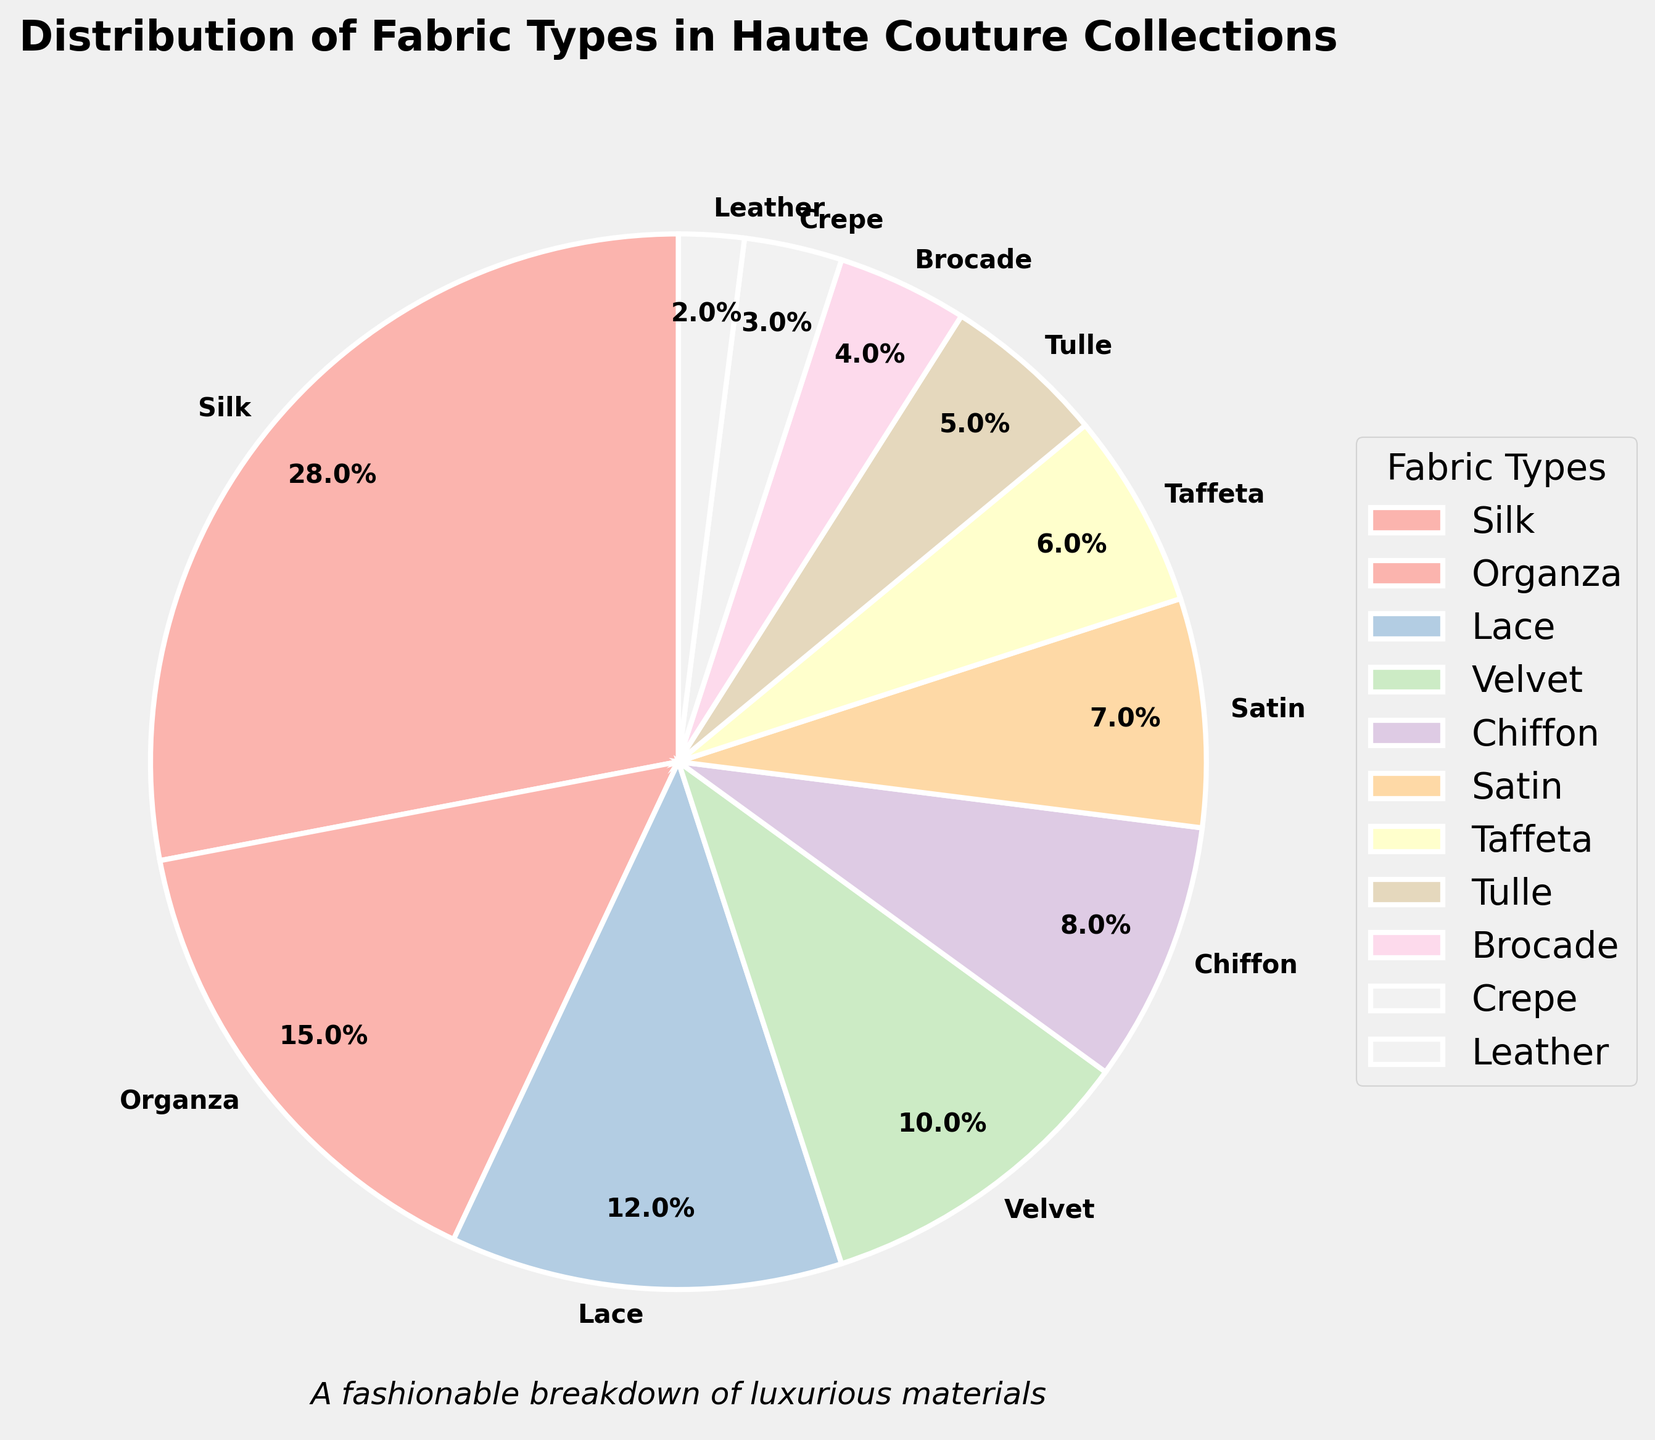Which fabric type occupies the largest portion of the pie chart? The largest portion can be identified by looking for the fabric type with the highest percentage value in the pie chart. Silk takes up the largest portion with 28%.
Answer: Silk How many fabric types constitute more than 10% of the total fabrics used? To determine this, look for fabric types with a percentage value greater than 10% on the pie chart. There are four fabric types: Silk (28%), Organza (15%), Lace (12%), Velvet (10%).
Answer: 4 What is the combined percentage of Silk, Organza, and Lace? Add the percentage values for Silk (28%), Organza (15%), and Lace (12%). 28 + 15 + 12 = 55%.
Answer: 55% Which three fabric types have the smallest representation in the pie chart? Identify the fabric types with the lowest percentage values. Leather (2%), Crepe (3%), and Brocade (4%) are the three smallest.
Answer: Leather, Crepe, Brocade How does the percentage of Tulle compare to that of Satin? Look at the pie chart to compare the percentage values. Tulle is 5%, and Satin is 7%, so Satin has a higher percentage than Tulle.
Answer: Satin Which fabric type is depicted in the lightest color in the pie chart? The lightest color in the pastel palette is typically represented first. Therefore, Silk, being the first and largest portion, is likely to be in the lightest color.
Answer: Silk What is the percentage difference between Chiffon and Velvet? Subtract the percentage of Chiffon from Velvet: 10% (Velvet) - 8% (Chiffon) = 2%.
Answer: 2% If these percentages were converted into numbers out of a total of 1000 fabrics, how many of those would be Taffeta? Convert Taffeta's percentage to a number out of 1000 by multiplying: 6% of 1000 = 0.06 * 1000 = 60.
Answer: 60 What is the sum of the percentages for Chiffon, Satin, and Taffeta? Add the percentages of these three fabric types: Chiffon (8%) + Satin (7%) + Taffeta (6%) = 8 + 7 + 6 = 21%.
Answer: 21% Which segment in the pie chart borders between Brocade and Crepe? Identify the fabric type located between Brocade (4%) and Crepe (3%), looking in clockwise or counterclockwise direction. Taffeta (6%) is positioned between Brocade and Crepe.
Answer: Taffeta 